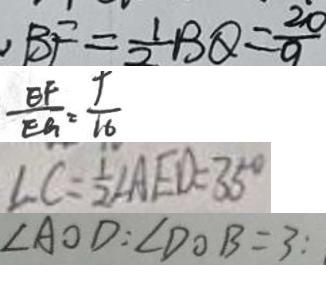<formula> <loc_0><loc_0><loc_500><loc_500>, B F = \frac { 1 } { 2 } B Q = \frac { 2 0 } { 9 } 
 \frac { E F } { E G } = \frac { 9 } { 1 6 } 
 \angle C = \frac { 1 } { 2 } \angle A E D = 3 5 ^ { \circ } 
 \angle A O D : \angle D O B = 3 :</formula> 